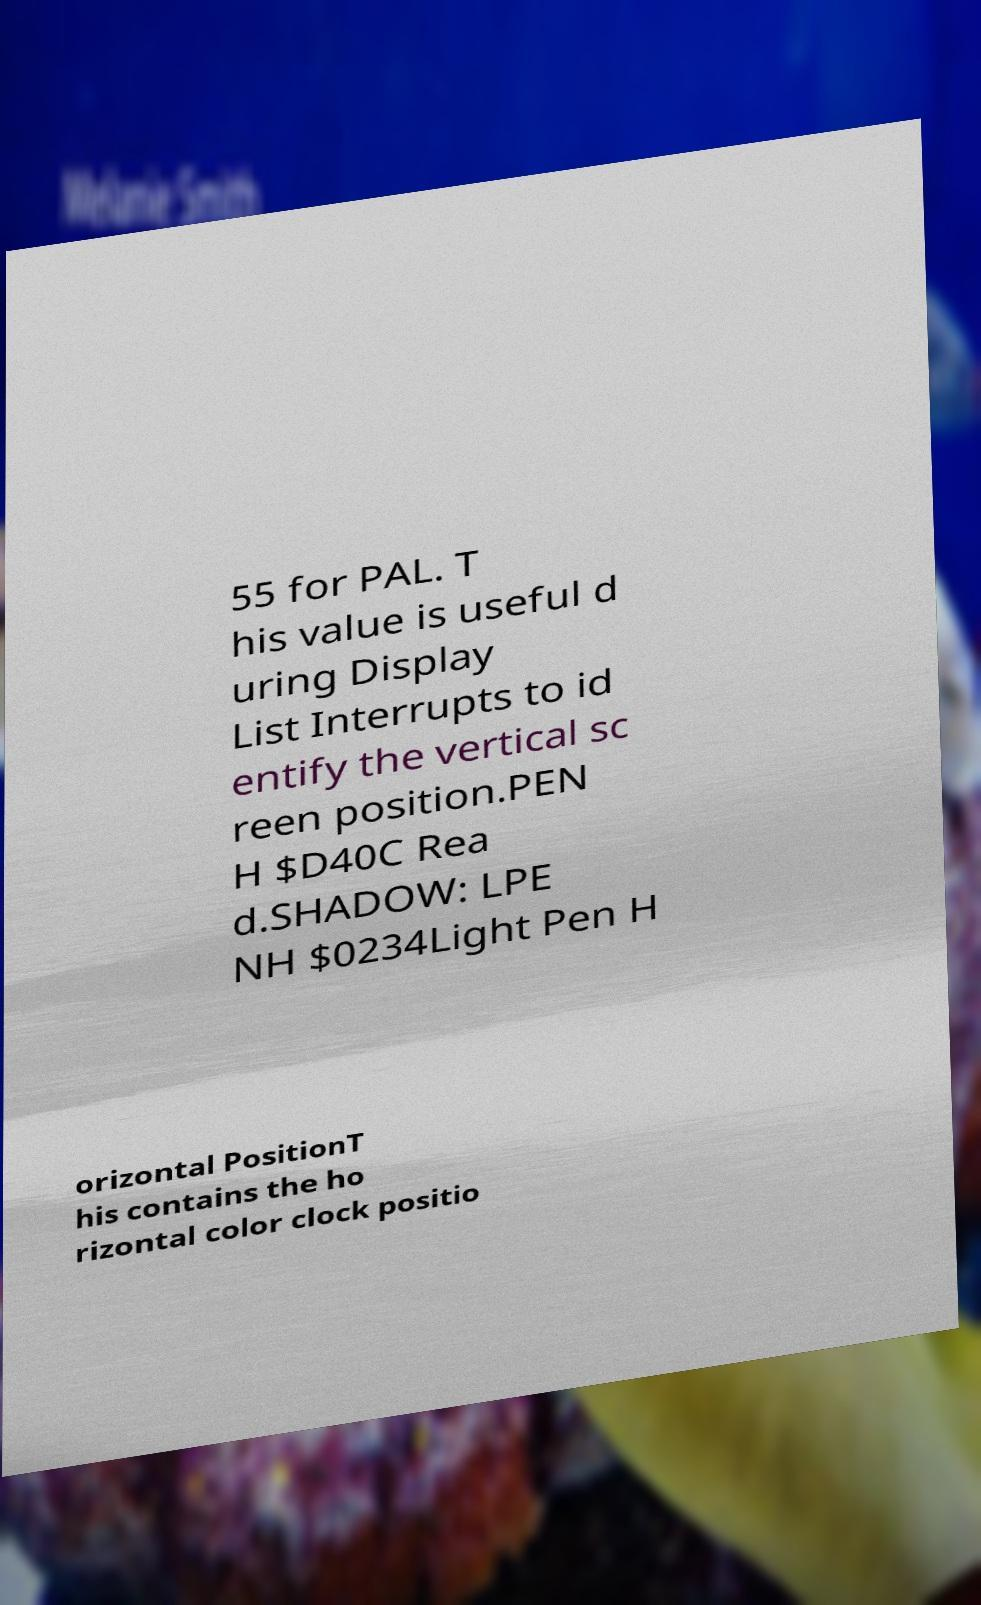What messages or text are displayed in this image? I need them in a readable, typed format. 55 for PAL. T his value is useful d uring Display List Interrupts to id entify the vertical sc reen position.PEN H $D40C Rea d.SHADOW: LPE NH $0234Light Pen H orizontal PositionT his contains the ho rizontal color clock positio 